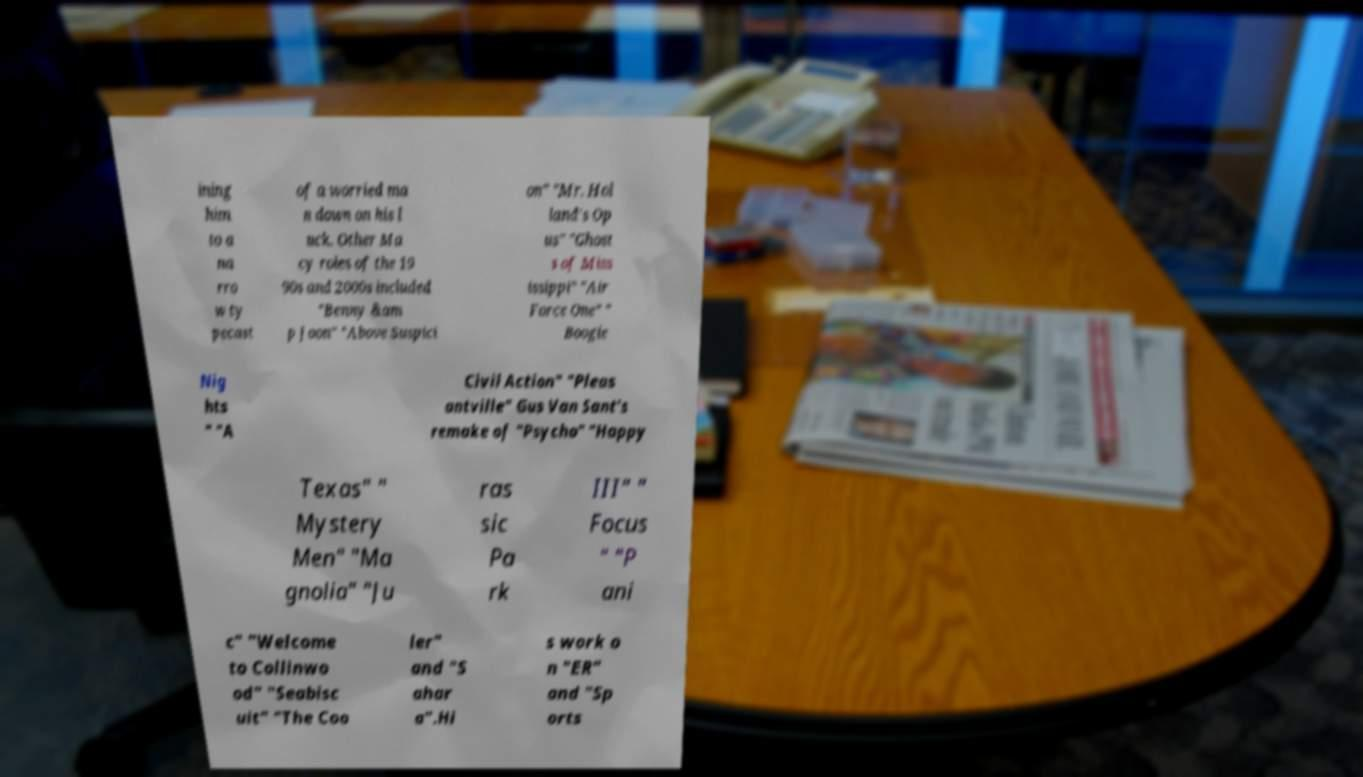Can you read and provide the text displayed in the image?This photo seems to have some interesting text. Can you extract and type it out for me? ining him to a na rro w ty pecast of a worried ma n down on his l uck. Other Ma cy roles of the 19 90s and 2000s included "Benny &am p Joon" "Above Suspici on" "Mr. Hol land's Op us" "Ghost s of Miss issippi" "Air Force One" " Boogie Nig hts " "A Civil Action" "Pleas antville" Gus Van Sant's remake of "Psycho" "Happy Texas" " Mystery Men" "Ma gnolia" "Ju ras sic Pa rk III" " Focus " "P ani c" "Welcome to Collinwo od" "Seabisc uit" "The Coo ler" and "S ahar a".Hi s work o n "ER" and "Sp orts 